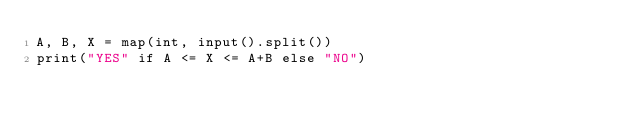<code> <loc_0><loc_0><loc_500><loc_500><_Python_>A, B, X = map(int, input().split())
print("YES" if A <= X <= A+B else "NO")</code> 